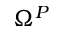<formula> <loc_0><loc_0><loc_500><loc_500>\Omega ^ { P }</formula> 